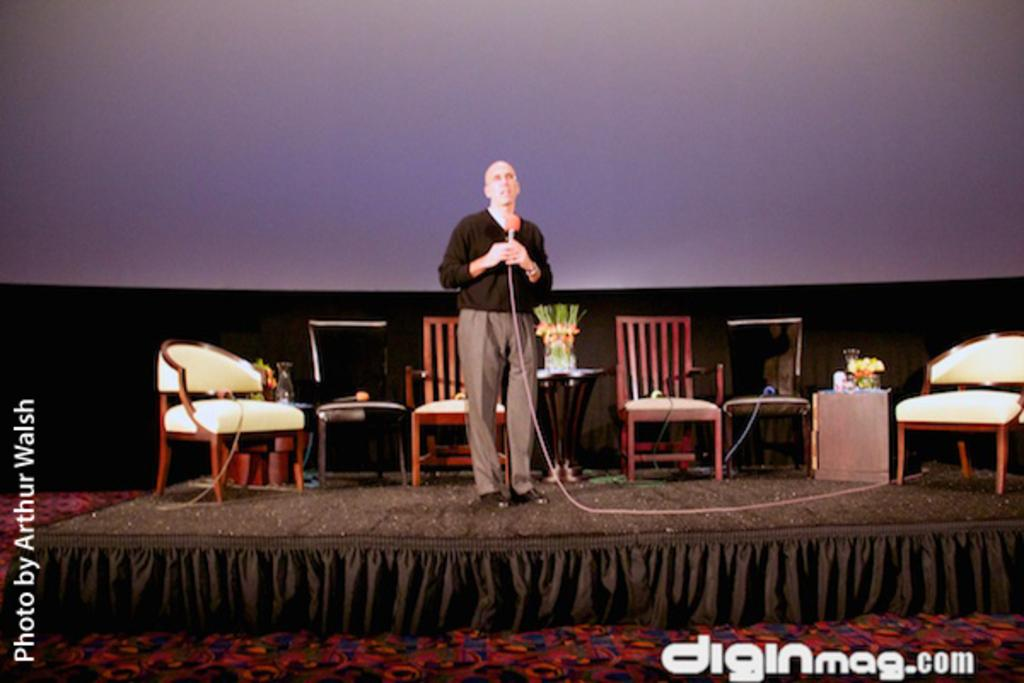What is the man in the image holding? The man is holding a mic. Where is the man located in the image? The man is standing on a stage. What can be seen in the background of the image? There are chairs and two tables in the background of the image. What is on the tables in the image? There are items on the tables. What type of pollution can be seen in the image? There is no pollution visible in the image. What kind of paper is the man using to stretch on the stage? The man is not using any paper to stretch on the stage; he is simply standing on it. 